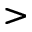Convert formula to latex. <formula><loc_0><loc_0><loc_500><loc_500>></formula> 